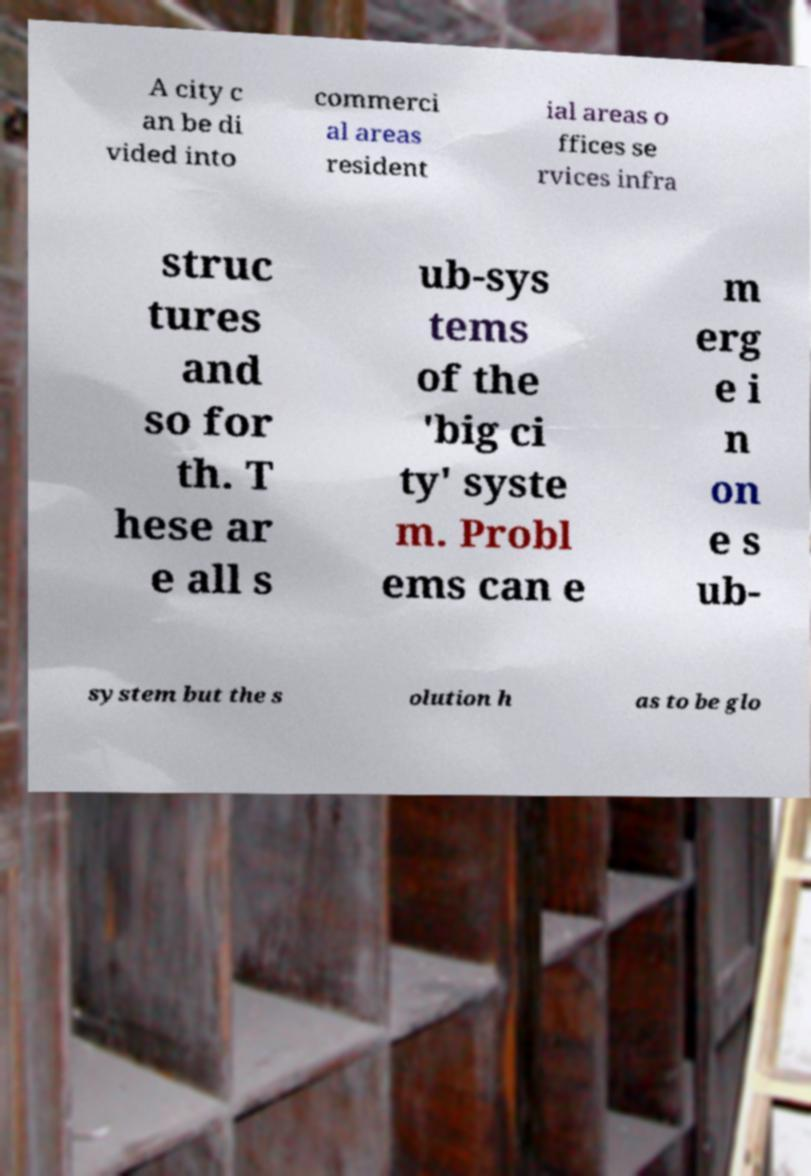Can you read and provide the text displayed in the image?This photo seems to have some interesting text. Can you extract and type it out for me? A city c an be di vided into commerci al areas resident ial areas o ffices se rvices infra struc tures and so for th. T hese ar e all s ub-sys tems of the 'big ci ty' syste m. Probl ems can e m erg e i n on e s ub- system but the s olution h as to be glo 